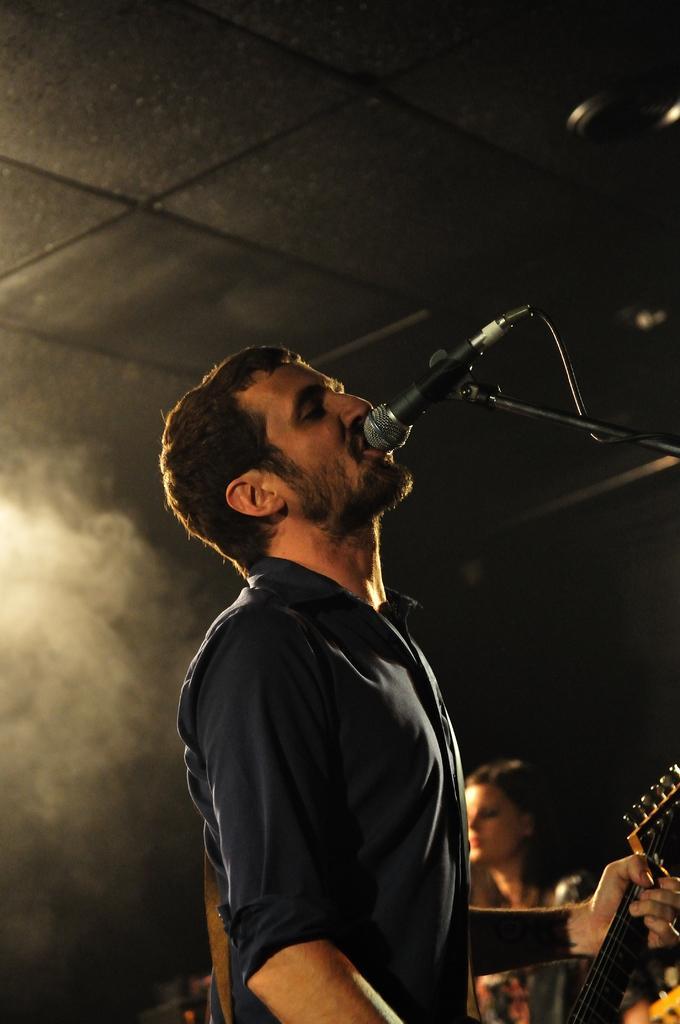Could you give a brief overview of what you see in this image? In this image i can see a man is holding a guitar and singing a song in front of a microphone. 